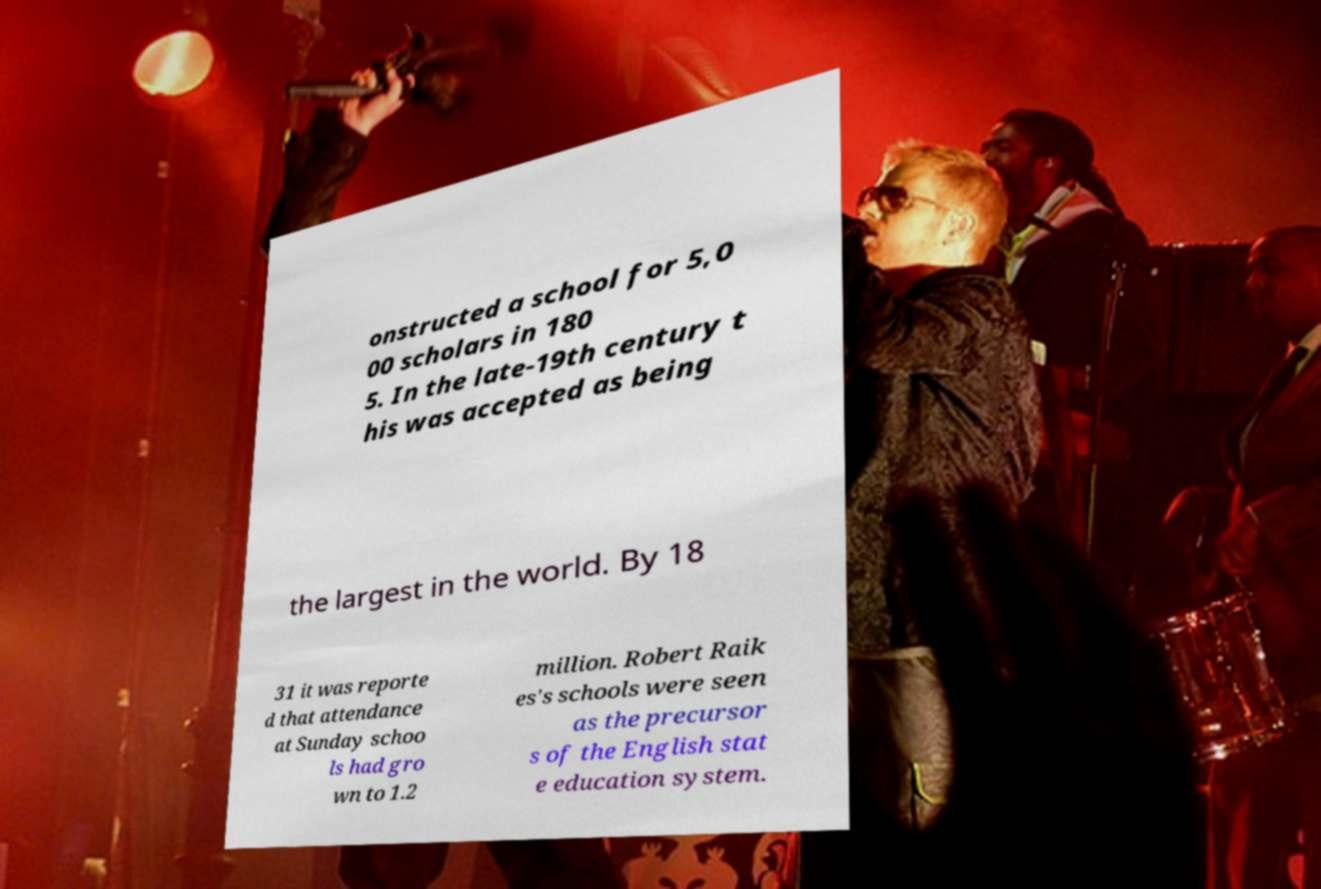What messages or text are displayed in this image? I need them in a readable, typed format. onstructed a school for 5,0 00 scholars in 180 5. In the late-19th century t his was accepted as being the largest in the world. By 18 31 it was reporte d that attendance at Sunday schoo ls had gro wn to 1.2 million. Robert Raik es's schools were seen as the precursor s of the English stat e education system. 